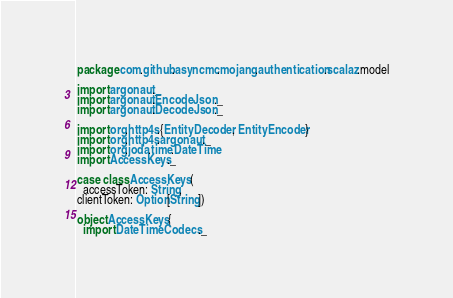Convert code to text. <code><loc_0><loc_0><loc_500><loc_500><_Scala_>package com.github.asyncmc.mojang.authentication.scalaz.model

import argonaut._
import argonaut.EncodeJson._
import argonaut.DecodeJson._

import org.http4s.{EntityDecoder, EntityEncoder}
import org.http4s.argonaut._
import org.joda.time.DateTime
import AccessKeys._

case class AccessKeys (
  accessToken: String,
clientToken: Option[String])

object AccessKeys {
  import DateTimeCodecs._
</code> 